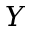Convert formula to latex. <formula><loc_0><loc_0><loc_500><loc_500>Y</formula> 